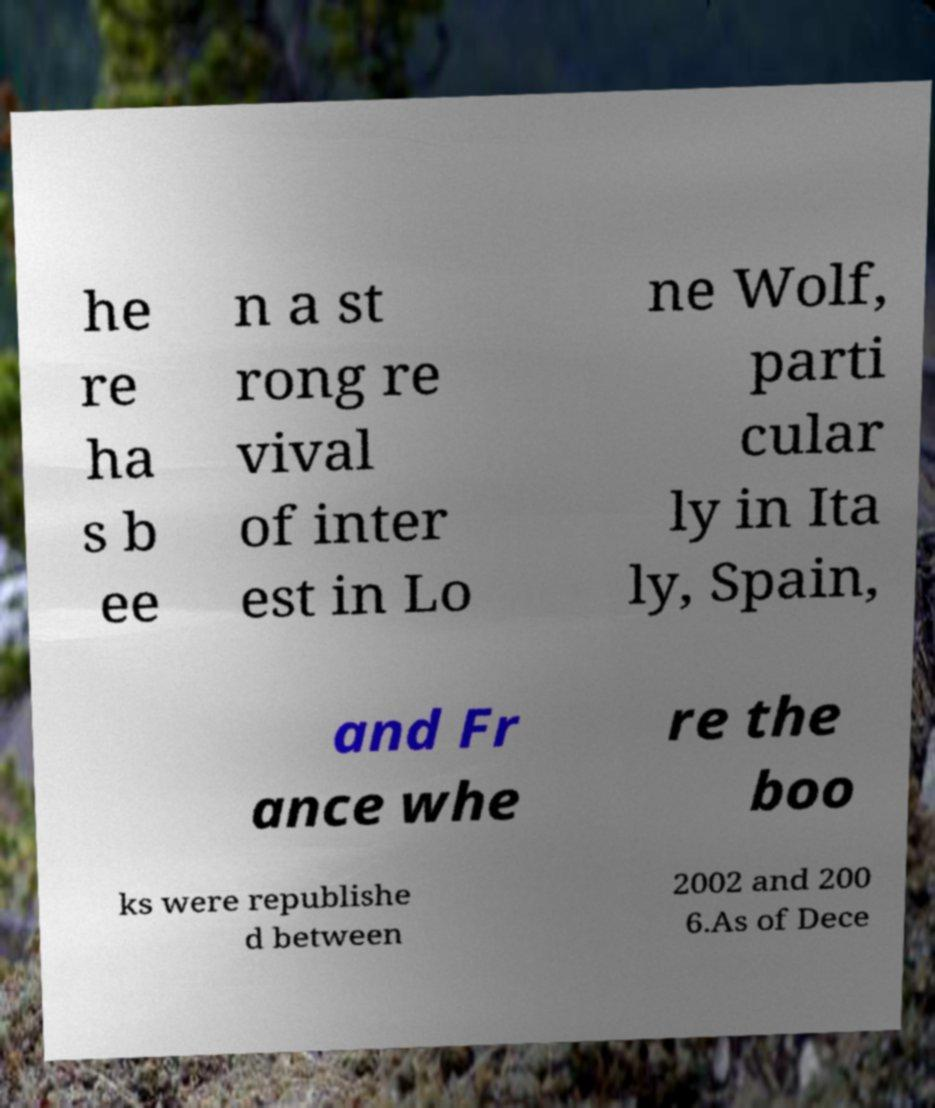Please identify and transcribe the text found in this image. he re ha s b ee n a st rong re vival of inter est in Lo ne Wolf, parti cular ly in Ita ly, Spain, and Fr ance whe re the boo ks were republishe d between 2002 and 200 6.As of Dece 